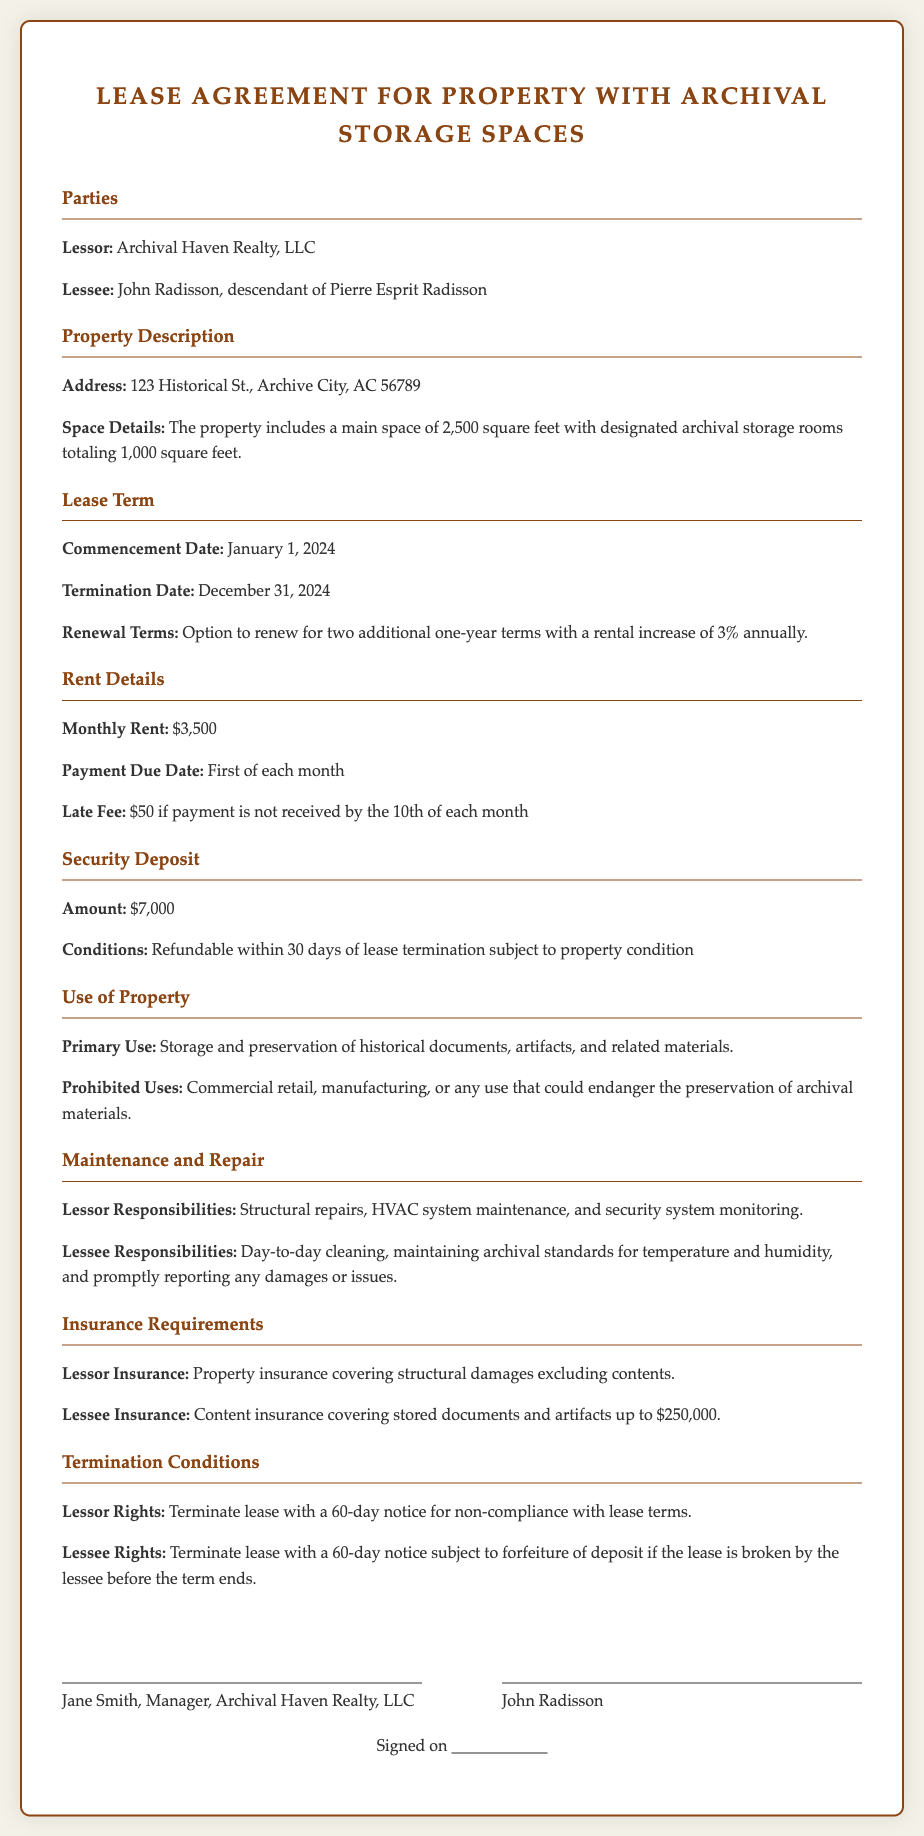What is the name of the lessor? The lessor is identified as Archival Haven Realty, LLC in the document.
Answer: Archival Haven Realty, LLC Who is the lessee? The lessee is named as John Radisson, who is a descendant of Pierre Esprit Radisson.
Answer: John Radisson, descendant of Pierre Esprit Radisson What is the monthly rent amount? The document states that the monthly rent is $3,500.
Answer: $3,500 What is the security deposit amount? The document specifies the security deposit amount as $7,000.
Answer: $7,000 What are the lessee's responsibilities listed? The lessee is responsible for day-to-day cleaning, maintaining archival standards for temperature and humidity, and promptly reporting any damages or issues.
Answer: Day-to-day cleaning, maintaining archival standards for temperature and humidity, and promptly reporting any damages or issues What is the primary use of the property according to the agreement? The agreement identifies the primary use of the property as storage and preservation of historical documents, artifacts, and related materials.
Answer: Storage and preservation of historical documents, artifacts, and related materials How long is the lease term? The lease term is specified to commence on January 1, 2024, and terminate on December 31, 2024, resulting in a one-year lease duration.
Answer: One year What is the required notice period for the lessor to terminate the lease? The document states that the lessor can terminate the lease with a 60-day notice.
Answer: 60 days What is the late fee for the rent payment? The document indicates that the late fee is $50 if payment is not received by the 10th of each month.
Answer: $50 